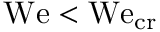<formula> <loc_0><loc_0><loc_500><loc_500>W e < W e _ { c r }</formula> 